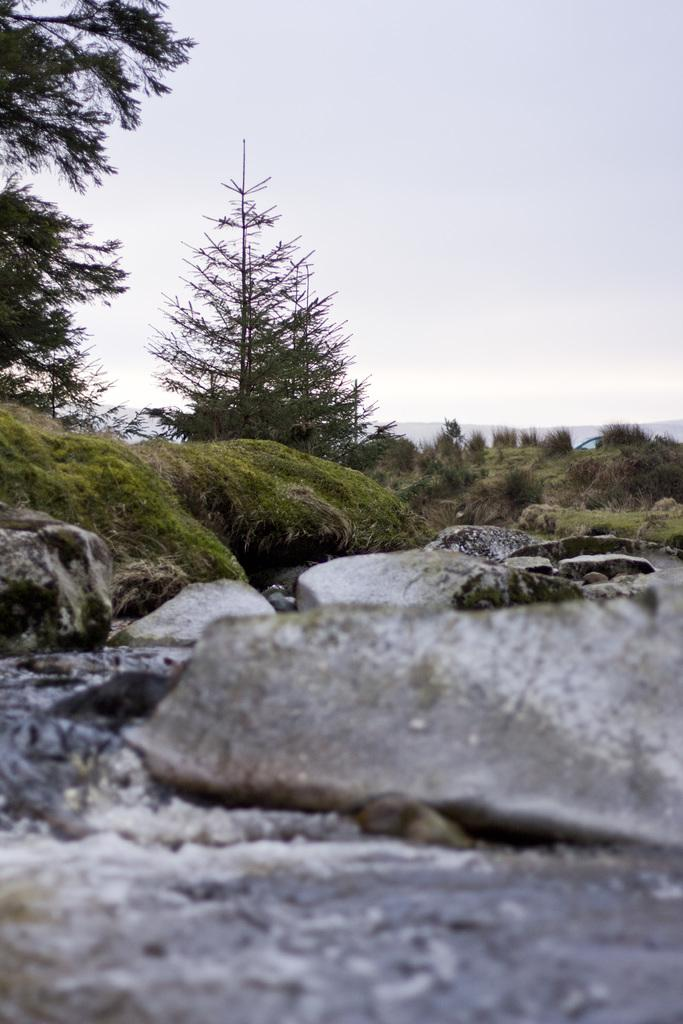What type of vegetation can be seen in the image? There is grass and trees in the image. What natural feature is present in the image? There is water in the image. What type of geological formation can be seen in the image? There are rocks and mountains in the image. What part of the natural environment is visible in the image? The sky is visible in the image. Based on the presence of the sky and the absence of artificial lighting, when do you think the image was taken? The image was likely taken during the day. How many lizards are sitting on the rocks in the image? There are no lizards present in the image. What color is the harbor in the image? There is no harbor present in the image. 